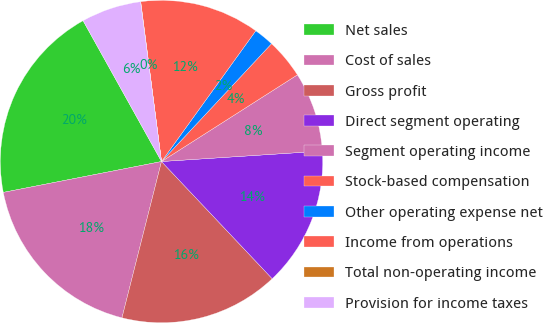Convert chart. <chart><loc_0><loc_0><loc_500><loc_500><pie_chart><fcel>Net sales<fcel>Cost of sales<fcel>Gross profit<fcel>Direct segment operating<fcel>Segment operating income<fcel>Stock-based compensation<fcel>Other operating expense net<fcel>Income from operations<fcel>Total non-operating income<fcel>Provision for income taxes<nl><fcel>19.98%<fcel>17.99%<fcel>15.99%<fcel>13.99%<fcel>8.0%<fcel>4.01%<fcel>2.01%<fcel>12.0%<fcel>0.02%<fcel>6.01%<nl></chart> 